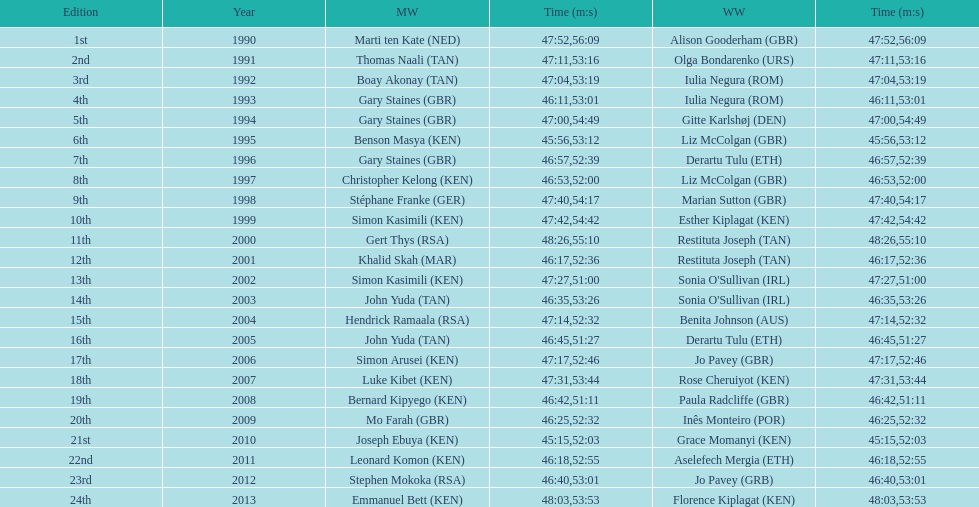What is the number of times, between 1990 and 2013, for britain not to win the men's or women's bupa great south run? 13. 